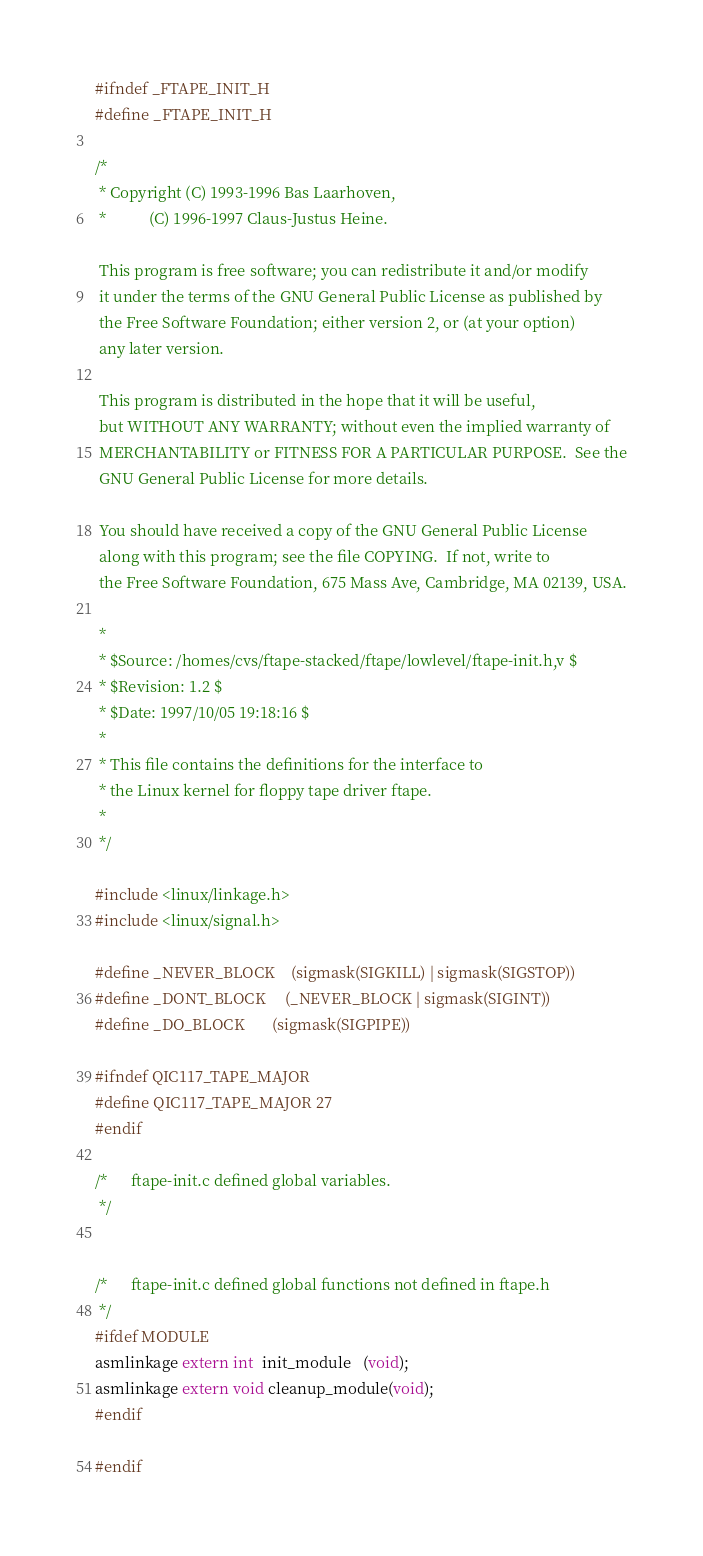Convert code to text. <code><loc_0><loc_0><loc_500><loc_500><_C_>#ifndef _FTAPE_INIT_H
#define _FTAPE_INIT_H

/*
 * Copyright (C) 1993-1996 Bas Laarhoven,
 *           (C) 1996-1997 Claus-Justus Heine.

 This program is free software; you can redistribute it and/or modify
 it under the terms of the GNU General Public License as published by
 the Free Software Foundation; either version 2, or (at your option)
 any later version.

 This program is distributed in the hope that it will be useful,
 but WITHOUT ANY WARRANTY; without even the implied warranty of
 MERCHANTABILITY or FITNESS FOR A PARTICULAR PURPOSE.  See the
 GNU General Public License for more details.

 You should have received a copy of the GNU General Public License
 along with this program; see the file COPYING.  If not, write to
 the Free Software Foundation, 675 Mass Ave, Cambridge, MA 02139, USA.

 *
 * $Source: /homes/cvs/ftape-stacked/ftape/lowlevel/ftape-init.h,v $
 * $Revision: 1.2 $
 * $Date: 1997/10/05 19:18:16 $
 *
 * This file contains the definitions for the interface to 
 * the Linux kernel for floppy tape driver ftape.
 *
 */

#include <linux/linkage.h>
#include <linux/signal.h>

#define _NEVER_BLOCK    (sigmask(SIGKILL) | sigmask(SIGSTOP))
#define _DONT_BLOCK     (_NEVER_BLOCK | sigmask(SIGINT))
#define _DO_BLOCK       (sigmask(SIGPIPE))

#ifndef QIC117_TAPE_MAJOR
#define QIC117_TAPE_MAJOR 27
#endif

/*      ftape-init.c defined global variables.
 */


/*      ftape-init.c defined global functions not defined in ftape.h
 */
#ifdef MODULE
asmlinkage extern int  init_module   (void);
asmlinkage extern void cleanup_module(void);
#endif

#endif
</code> 